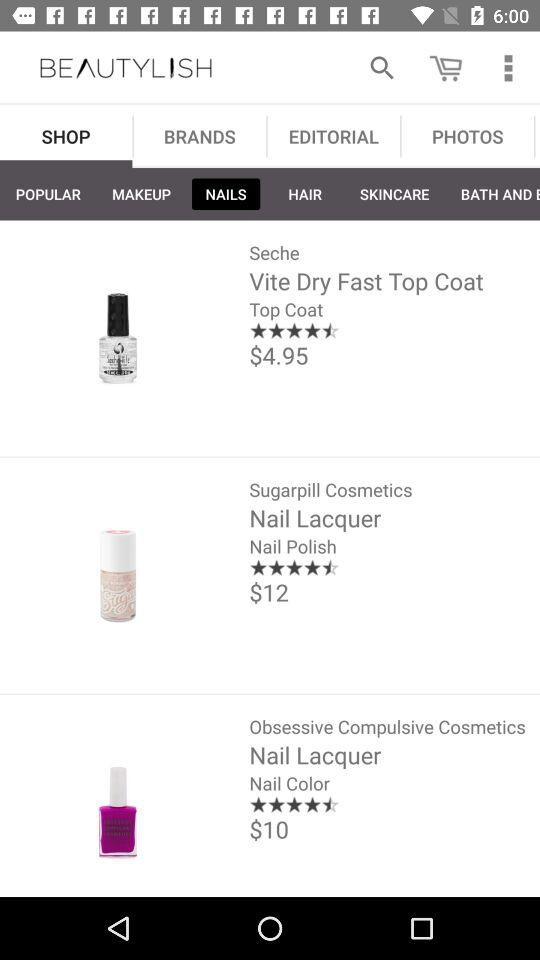What are the sign-in options? The sign-in options are "Google+", "Facebook" and "E-mail". 